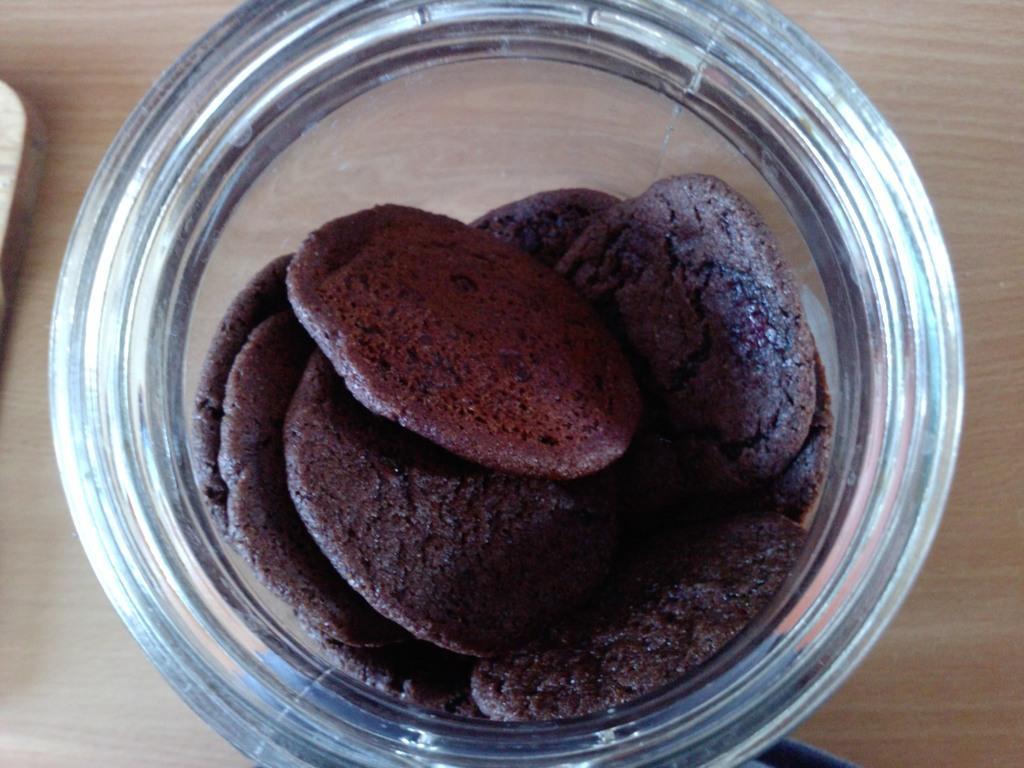Please provide a concise description of this image. In this picture we can see some food item are placed in the jar, which is placed on the wooden thing. 